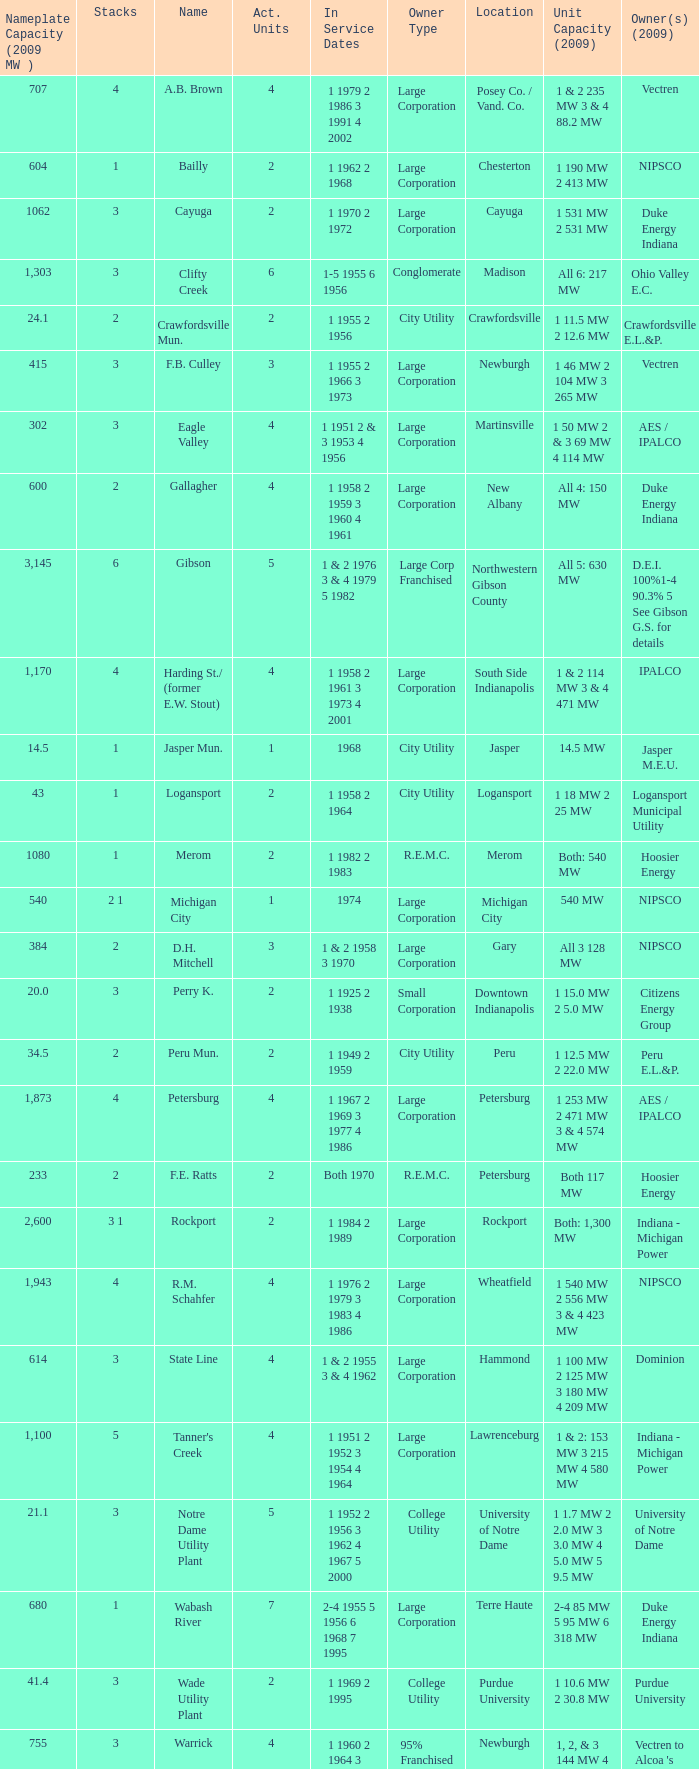What is the contact number for service dates at hoosier energy in petersburg? 1.0. 